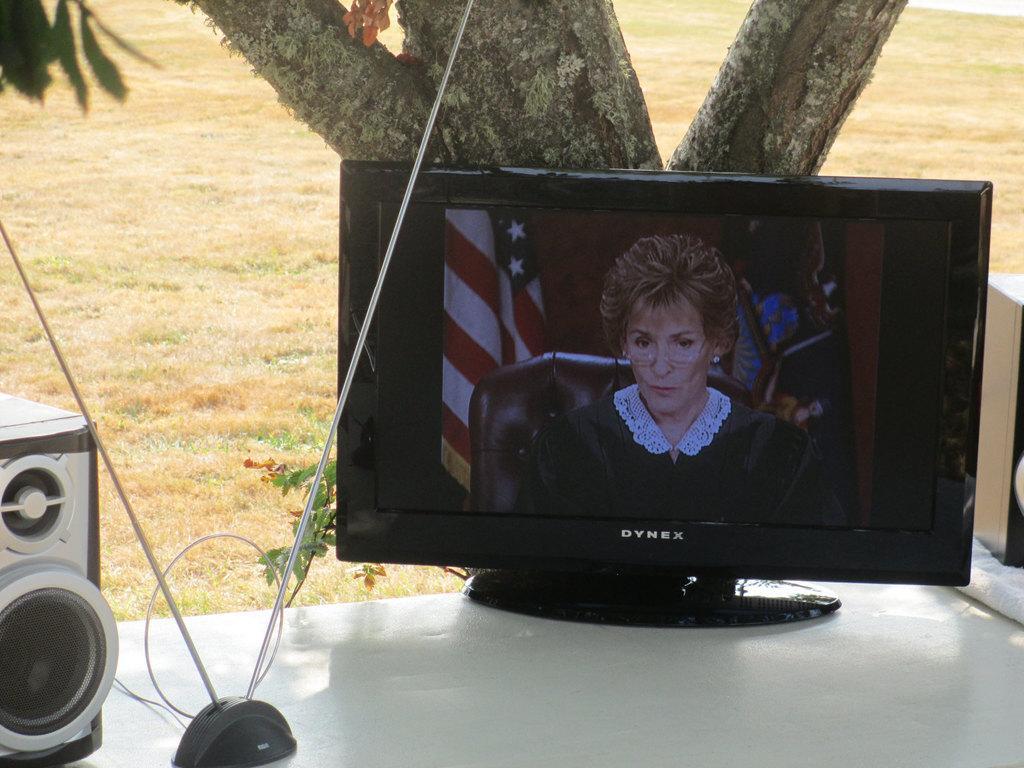Please provide a concise description of this image. In the image in the center we can see one table. On the table,we can see speakers,cloth,black color object and monitor. In the monitor,we can see one flag and one person sitting on the chair. In the background there is a tree and grass. 